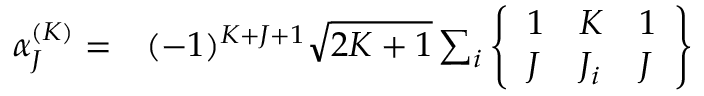Convert formula to latex. <formula><loc_0><loc_0><loc_500><loc_500>\begin{array} { r l } { \alpha _ { J } ^ { ( K ) } = } & ( - 1 ) ^ { K + J + 1 } \sqrt { 2 K + 1 } \sum _ { i } \left \{ \begin{array} { l l l } { 1 } & { K } & { 1 } \\ { J } & { J _ { i } } & { J } \end{array} \right \} } \end{array}</formula> 